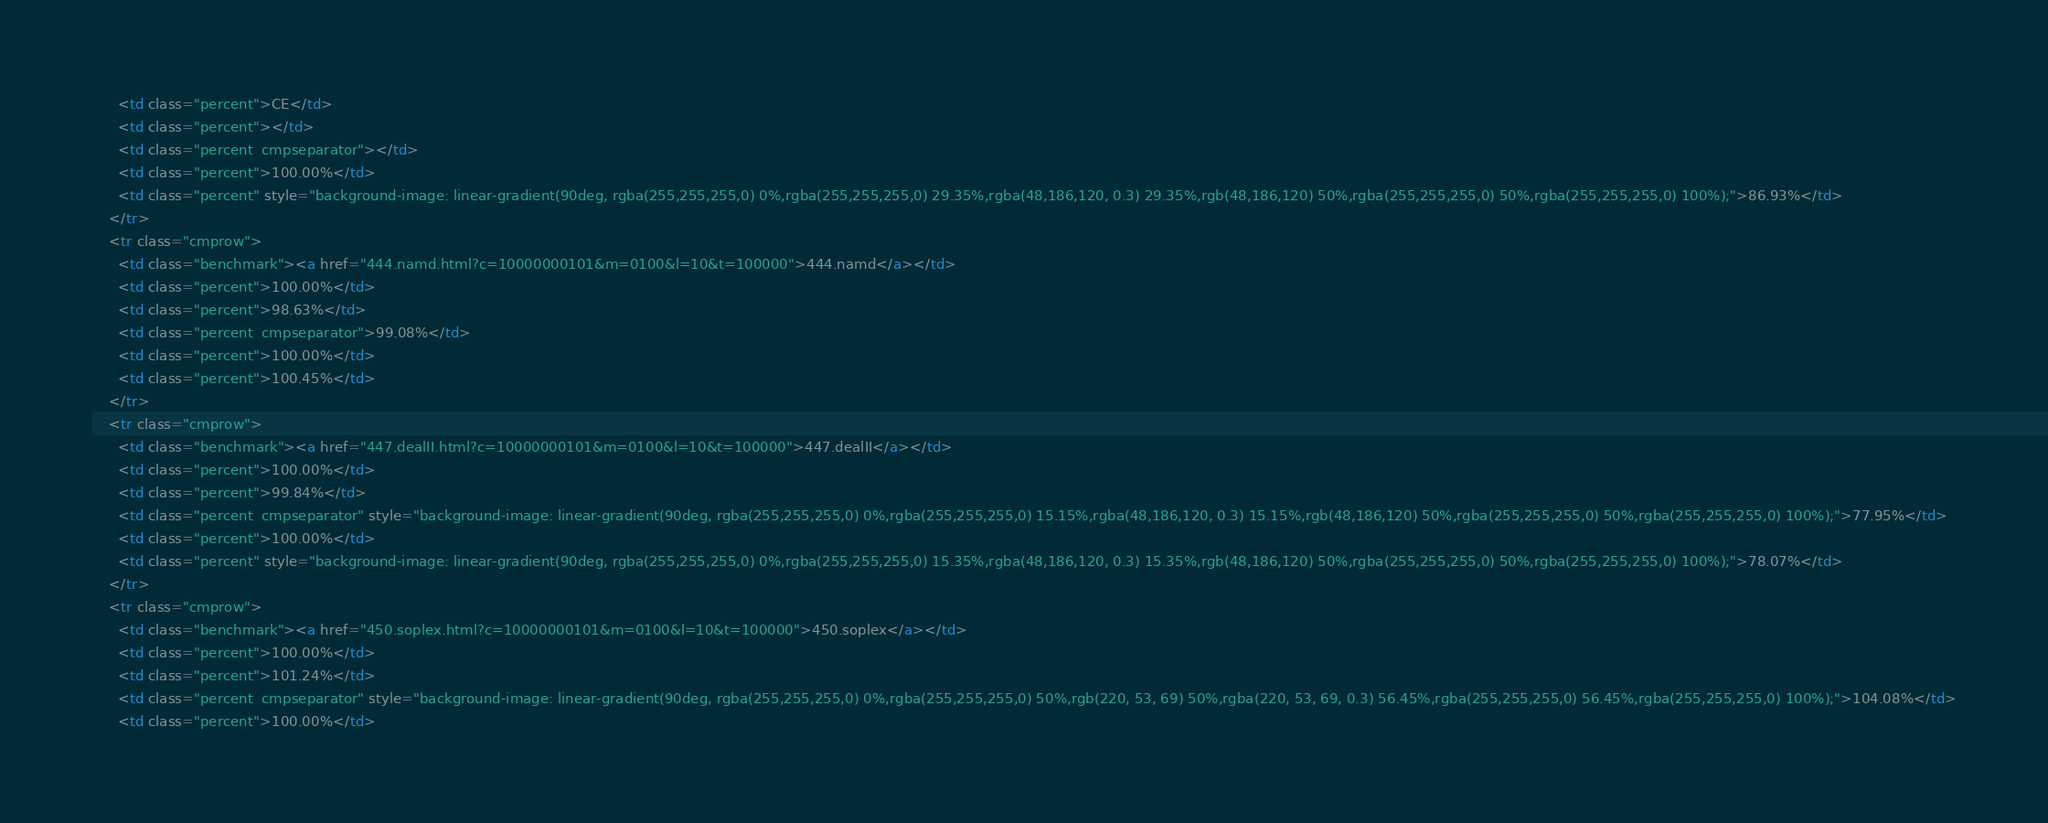Convert code to text. <code><loc_0><loc_0><loc_500><loc_500><_HTML_>      <td class="percent">CE</td>
      <td class="percent"></td>
      <td class="percent  cmpseparator"></td>
      <td class="percent">100.00%</td>
      <td class="percent" style="background-image: linear-gradient(90deg, rgba(255,255,255,0) 0%,rgba(255,255,255,0) 29.35%,rgba(48,186,120, 0.3) 29.35%,rgb(48,186,120) 50%,rgba(255,255,255,0) 50%,rgba(255,255,255,0) 100%);">86.93%</td>
    </tr>
    <tr class="cmprow">
      <td class="benchmark"><a href="444.namd.html?c=10000000101&m=0100&l=10&t=100000">444.namd</a></td>
      <td class="percent">100.00%</td>
      <td class="percent">98.63%</td>
      <td class="percent  cmpseparator">99.08%</td>
      <td class="percent">100.00%</td>
      <td class="percent">100.45%</td>
    </tr>
    <tr class="cmprow">
      <td class="benchmark"><a href="447.dealII.html?c=10000000101&m=0100&l=10&t=100000">447.dealII</a></td>
      <td class="percent">100.00%</td>
      <td class="percent">99.84%</td>
      <td class="percent  cmpseparator" style="background-image: linear-gradient(90deg, rgba(255,255,255,0) 0%,rgba(255,255,255,0) 15.15%,rgba(48,186,120, 0.3) 15.15%,rgb(48,186,120) 50%,rgba(255,255,255,0) 50%,rgba(255,255,255,0) 100%);">77.95%</td>
      <td class="percent">100.00%</td>
      <td class="percent" style="background-image: linear-gradient(90deg, rgba(255,255,255,0) 0%,rgba(255,255,255,0) 15.35%,rgba(48,186,120, 0.3) 15.35%,rgb(48,186,120) 50%,rgba(255,255,255,0) 50%,rgba(255,255,255,0) 100%);">78.07%</td>
    </tr>
    <tr class="cmprow">
      <td class="benchmark"><a href="450.soplex.html?c=10000000101&m=0100&l=10&t=100000">450.soplex</a></td>
      <td class="percent">100.00%</td>
      <td class="percent">101.24%</td>
      <td class="percent  cmpseparator" style="background-image: linear-gradient(90deg, rgba(255,255,255,0) 0%,rgba(255,255,255,0) 50%,rgb(220, 53, 69) 50%,rgba(220, 53, 69, 0.3) 56.45%,rgba(255,255,255,0) 56.45%,rgba(255,255,255,0) 100%);">104.08%</td>
      <td class="percent">100.00%</td></code> 